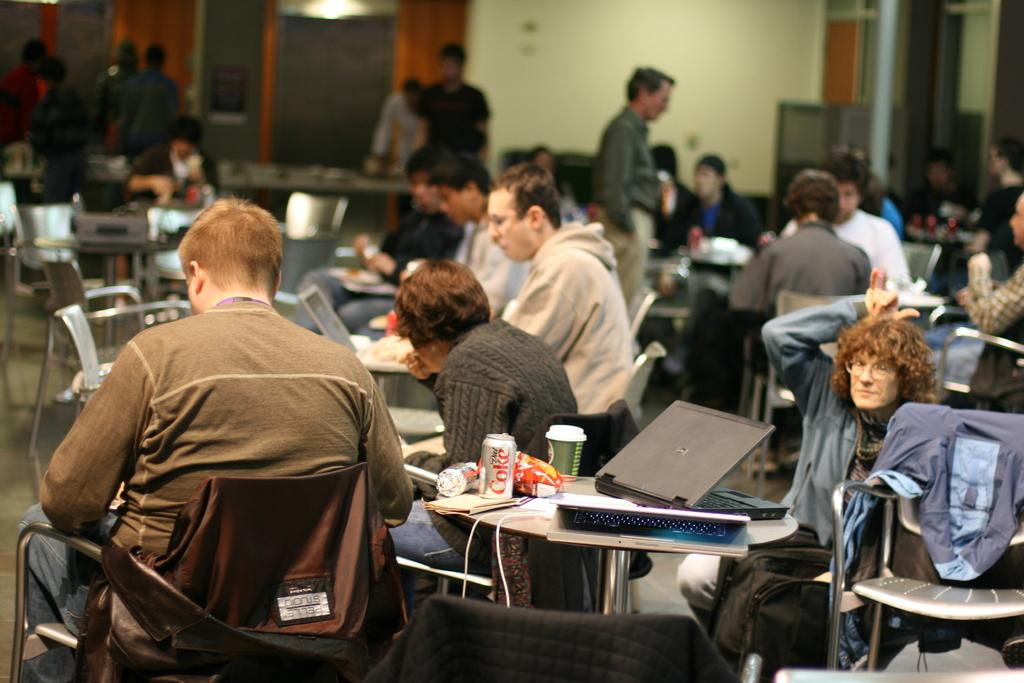What are the people near the table doing? There are people sitting on chairs near a table. What objects can be seen on the table? There are laptops, tins, cups, and food items on the table. What might the people be using the laptops for? The laptops on the table might be used for work, browsing the internet, or other activities. What type of containers are on the table? The tins on the table are likely used for storing or serving food items. What flavor of toothpaste is being used by the people in the image? There is no toothpaste present in the image; it features people sitting near a table with laptops, tins, cups, and food items. How does the governor interact with the cups in the image? There is no governor present in the image, and therefore no interaction with the cups can be observed. 